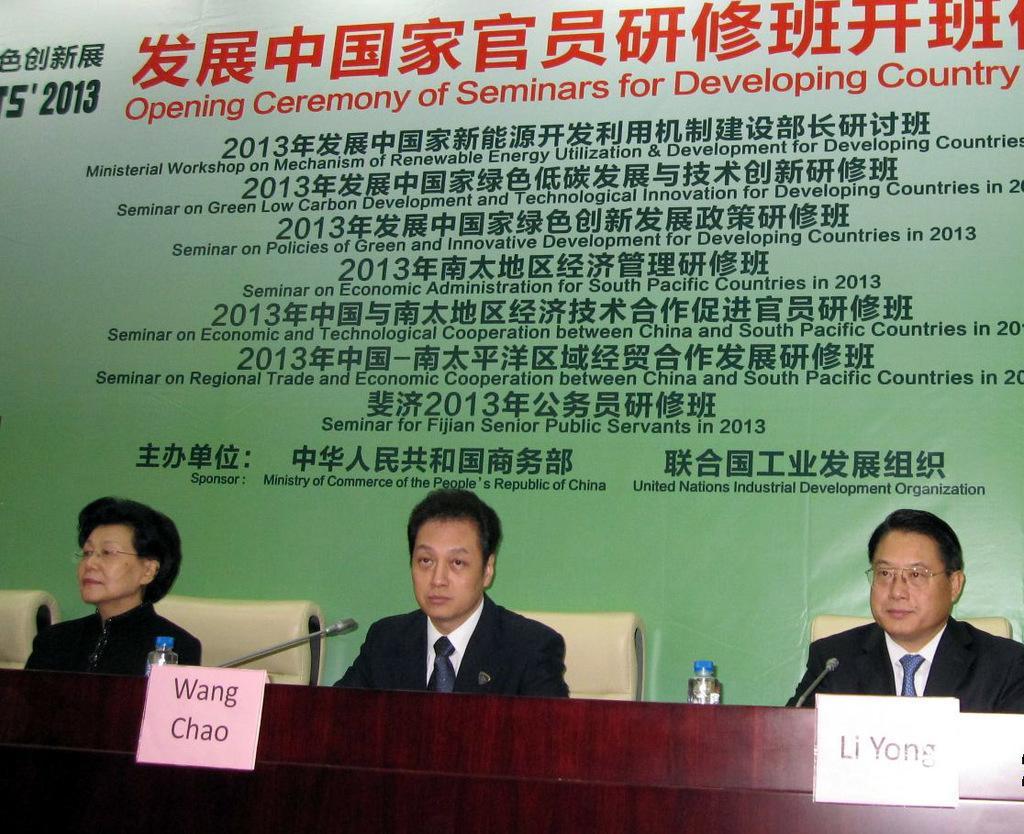Could you give a brief overview of what you see in this image? At the bottom I can see three persons are sitting on the chairs in front of a table on which I can see boards, bottles and mike's. In the background I can see text and a poster. This image is taken may be in a hall. 